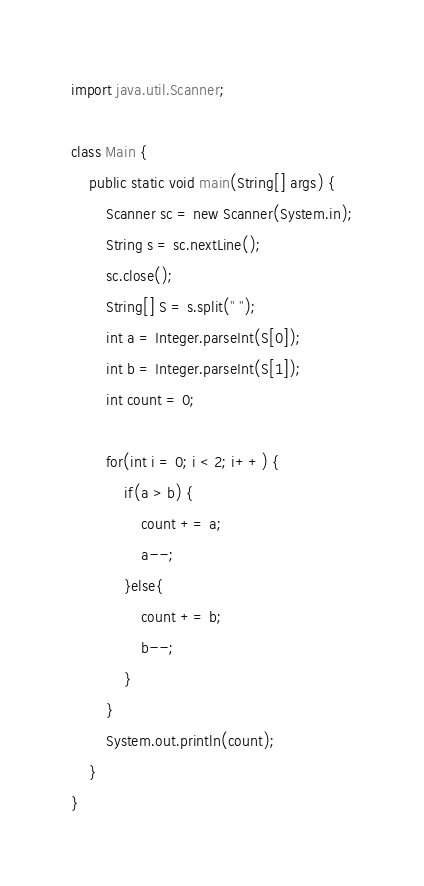<code> <loc_0><loc_0><loc_500><loc_500><_Java_>import java.util.Scanner;

class Main {
    public static void main(String[] args) {
        Scanner sc = new Scanner(System.in);
        String s = sc.nextLine();
        sc.close();
        String[] S = s.split(" ");
        int a = Integer.parseInt(S[0]);
        int b = Integer.parseInt(S[1]);
        int count = 0;

        for(int i = 0; i < 2; i++) {
            if(a > b) {
                count += a;
                a--;             
            }else{
                count += b;
                b--;
            }
        }
        System.out.println(count);
    }
}</code> 